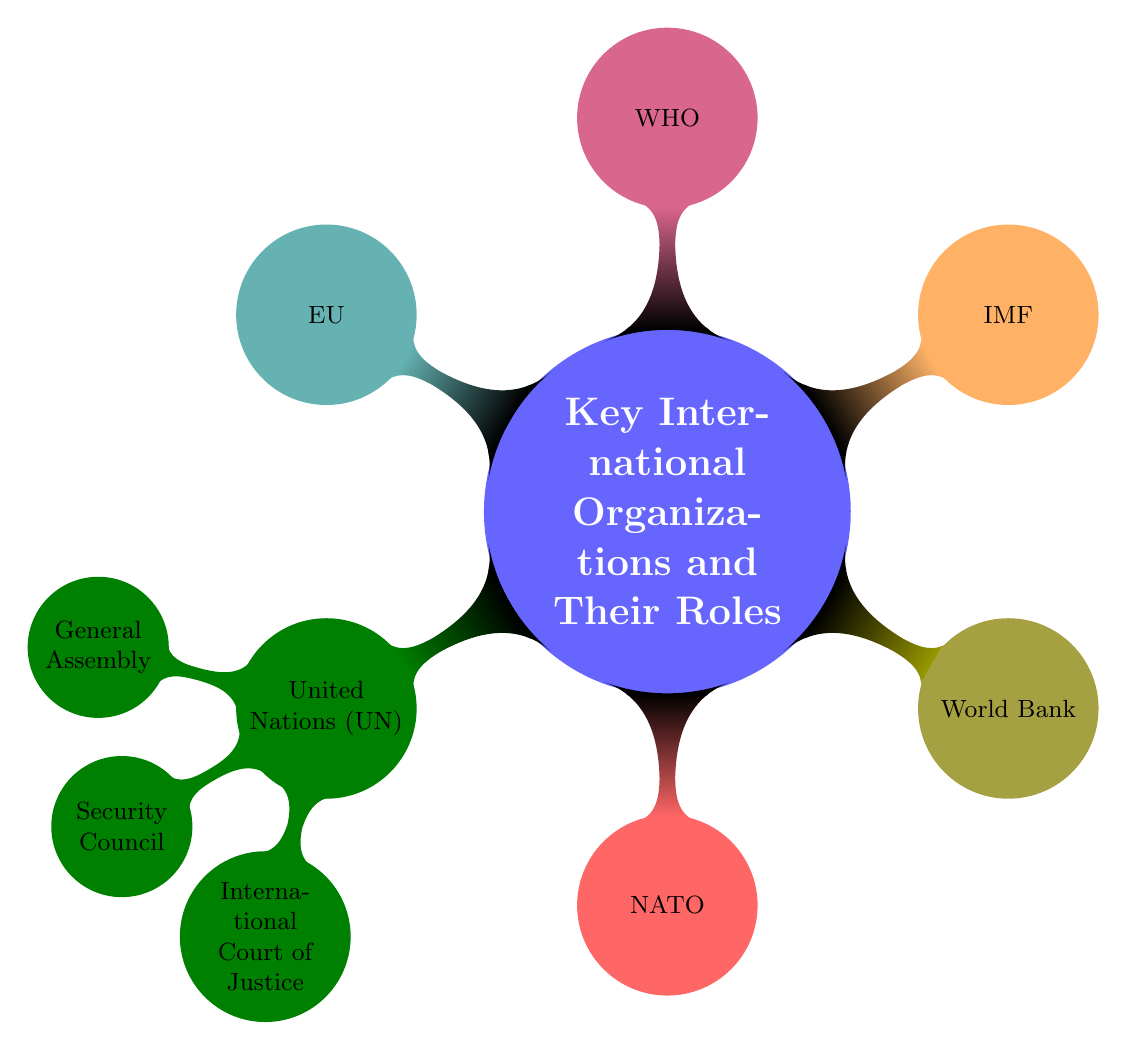What is the main topic of the mind map? The central node presents the topic under which all sub-nodes and their roles are organized. The main topic, which is mentioned in the central node, is "Key International Organizations and Their Roles".
Answer: Key International Organizations and Their Roles How many sub-nodes are there under the United Nations? By counting the branches off the United Nations node, we find there are three specific sub-nodes: General Assembly, Security Council, and International Court of Justice.
Answer: 3 What is the role of the World Bank? The World Bank node describes its role in helping developing countries. It states that it "Provides financial and technical assistance to developing countries for development programs".
Answer: Provides financial and technical assistance to developing countries for development programs Which organization is a military alliance for mutual defense? The node for NATO specifies it as a military alliance established for mutual defense, indicating its purpose among international organizations.
Answer: NATO How many members are in the Security Council? The node for the Security Council explicitly states that it has 15 members, which is a specific detail provided in the role description.
Answer: 15 What type of organization is the European Union? The EU node indicates it is a "Political and economic union of 27 European countries", effectively describing its nature within international organizations.
Answer: Political and economic union of 27 European countries What are the roles of the General Assembly, Security Council, and International Court of Justice? To answer this, we look at each node under the United Nations. The General Assembly is for international policy making, the Security Council maintains peace and security, and the International Court of Justice settles disputes between states. Thus, it requires us to combine roles from each sub-node.
Answer: Deliberative assembly of all member states for international policy making, maintains international peace and security with 15 members, principal judicial body to settle disputes between states Which organization focuses on international health? The node labeled WHO refers explicitly to its role as the organization that directs international health within the UN and leads global health responses.
Answer: WHO What does the International Monetary Fund (IMF) provide? The IMF node describes its role in ensuring monetary stability through cooperation and support among nations. Answering this question requires knowing the specific role of the IMF as stated in the diagram.
Answer: Ensures the stability of the international monetary system through monetary cooperation, advice, and financial support 